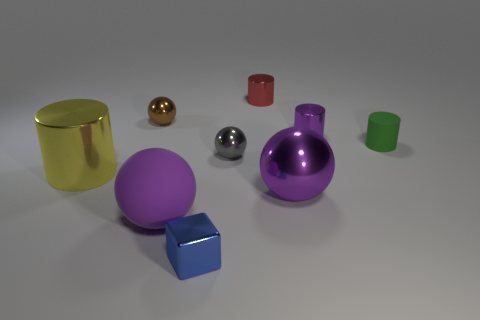Subtract all tiny gray metal spheres. How many spheres are left? 3 Subtract all brown balls. How many balls are left? 3 Subtract all cylinders. How many objects are left? 5 Subtract 4 balls. How many balls are left? 0 Add 1 small metal cylinders. How many objects exist? 10 Add 4 red metal cylinders. How many red metal cylinders are left? 5 Add 8 large purple spheres. How many large purple spheres exist? 10 Subtract 1 purple cylinders. How many objects are left? 8 Subtract all brown blocks. Subtract all cyan spheres. How many blocks are left? 1 Subtract all purple cylinders. How many gray cubes are left? 0 